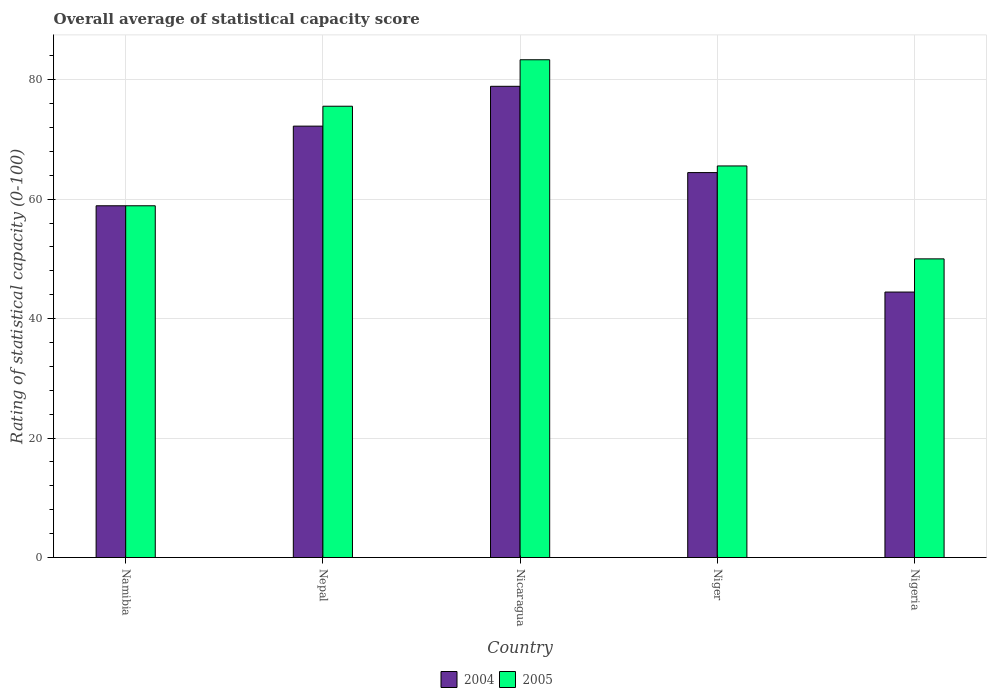How many different coloured bars are there?
Give a very brief answer. 2. How many groups of bars are there?
Provide a short and direct response. 5. How many bars are there on the 5th tick from the left?
Keep it short and to the point. 2. What is the label of the 2nd group of bars from the left?
Offer a very short reply. Nepal. What is the rating of statistical capacity in 2005 in Namibia?
Provide a short and direct response. 58.89. Across all countries, what is the maximum rating of statistical capacity in 2005?
Make the answer very short. 83.33. Across all countries, what is the minimum rating of statistical capacity in 2004?
Offer a terse response. 44.44. In which country was the rating of statistical capacity in 2005 maximum?
Provide a short and direct response. Nicaragua. In which country was the rating of statistical capacity in 2005 minimum?
Make the answer very short. Nigeria. What is the total rating of statistical capacity in 2005 in the graph?
Provide a succinct answer. 333.33. What is the difference between the rating of statistical capacity in 2004 in Namibia and that in Nigeria?
Make the answer very short. 14.44. What is the difference between the rating of statistical capacity in 2004 in Niger and the rating of statistical capacity in 2005 in Nicaragua?
Offer a very short reply. -18.89. What is the average rating of statistical capacity in 2004 per country?
Offer a very short reply. 63.78. In how many countries, is the rating of statistical capacity in 2004 greater than 52?
Offer a terse response. 4. What is the ratio of the rating of statistical capacity in 2005 in Nepal to that in Nigeria?
Your response must be concise. 1.51. Is the rating of statistical capacity in 2004 in Namibia less than that in Niger?
Ensure brevity in your answer.  Yes. Is the difference between the rating of statistical capacity in 2005 in Nepal and Nigeria greater than the difference between the rating of statistical capacity in 2004 in Nepal and Nigeria?
Keep it short and to the point. No. What is the difference between the highest and the second highest rating of statistical capacity in 2005?
Keep it short and to the point. -10. What is the difference between the highest and the lowest rating of statistical capacity in 2005?
Your response must be concise. 33.33. In how many countries, is the rating of statistical capacity in 2004 greater than the average rating of statistical capacity in 2004 taken over all countries?
Your answer should be compact. 3. How many bars are there?
Your answer should be very brief. 10. How many countries are there in the graph?
Provide a short and direct response. 5. What is the difference between two consecutive major ticks on the Y-axis?
Your response must be concise. 20. Does the graph contain any zero values?
Provide a short and direct response. No. Does the graph contain grids?
Your answer should be compact. Yes. What is the title of the graph?
Keep it short and to the point. Overall average of statistical capacity score. What is the label or title of the X-axis?
Your answer should be compact. Country. What is the label or title of the Y-axis?
Give a very brief answer. Rating of statistical capacity (0-100). What is the Rating of statistical capacity (0-100) in 2004 in Namibia?
Offer a terse response. 58.89. What is the Rating of statistical capacity (0-100) of 2005 in Namibia?
Your response must be concise. 58.89. What is the Rating of statistical capacity (0-100) of 2004 in Nepal?
Your answer should be very brief. 72.22. What is the Rating of statistical capacity (0-100) in 2005 in Nepal?
Your answer should be very brief. 75.56. What is the Rating of statistical capacity (0-100) in 2004 in Nicaragua?
Make the answer very short. 78.89. What is the Rating of statistical capacity (0-100) in 2005 in Nicaragua?
Keep it short and to the point. 83.33. What is the Rating of statistical capacity (0-100) in 2004 in Niger?
Provide a succinct answer. 64.44. What is the Rating of statistical capacity (0-100) of 2005 in Niger?
Your response must be concise. 65.56. What is the Rating of statistical capacity (0-100) of 2004 in Nigeria?
Your response must be concise. 44.44. What is the Rating of statistical capacity (0-100) in 2005 in Nigeria?
Offer a very short reply. 50. Across all countries, what is the maximum Rating of statistical capacity (0-100) of 2004?
Provide a short and direct response. 78.89. Across all countries, what is the maximum Rating of statistical capacity (0-100) of 2005?
Your response must be concise. 83.33. Across all countries, what is the minimum Rating of statistical capacity (0-100) of 2004?
Offer a terse response. 44.44. What is the total Rating of statistical capacity (0-100) in 2004 in the graph?
Provide a succinct answer. 318.89. What is the total Rating of statistical capacity (0-100) of 2005 in the graph?
Give a very brief answer. 333.33. What is the difference between the Rating of statistical capacity (0-100) in 2004 in Namibia and that in Nepal?
Ensure brevity in your answer.  -13.33. What is the difference between the Rating of statistical capacity (0-100) in 2005 in Namibia and that in Nepal?
Keep it short and to the point. -16.67. What is the difference between the Rating of statistical capacity (0-100) in 2005 in Namibia and that in Nicaragua?
Your response must be concise. -24.44. What is the difference between the Rating of statistical capacity (0-100) in 2004 in Namibia and that in Niger?
Your answer should be compact. -5.56. What is the difference between the Rating of statistical capacity (0-100) in 2005 in Namibia and that in Niger?
Offer a terse response. -6.67. What is the difference between the Rating of statistical capacity (0-100) in 2004 in Namibia and that in Nigeria?
Provide a succinct answer. 14.44. What is the difference between the Rating of statistical capacity (0-100) of 2005 in Namibia and that in Nigeria?
Your response must be concise. 8.89. What is the difference between the Rating of statistical capacity (0-100) in 2004 in Nepal and that in Nicaragua?
Provide a short and direct response. -6.67. What is the difference between the Rating of statistical capacity (0-100) of 2005 in Nepal and that in Nicaragua?
Your response must be concise. -7.78. What is the difference between the Rating of statistical capacity (0-100) of 2004 in Nepal and that in Niger?
Provide a short and direct response. 7.78. What is the difference between the Rating of statistical capacity (0-100) in 2004 in Nepal and that in Nigeria?
Offer a terse response. 27.78. What is the difference between the Rating of statistical capacity (0-100) in 2005 in Nepal and that in Nigeria?
Ensure brevity in your answer.  25.56. What is the difference between the Rating of statistical capacity (0-100) in 2004 in Nicaragua and that in Niger?
Your answer should be compact. 14.44. What is the difference between the Rating of statistical capacity (0-100) of 2005 in Nicaragua and that in Niger?
Provide a succinct answer. 17.78. What is the difference between the Rating of statistical capacity (0-100) in 2004 in Nicaragua and that in Nigeria?
Give a very brief answer. 34.44. What is the difference between the Rating of statistical capacity (0-100) in 2005 in Nicaragua and that in Nigeria?
Give a very brief answer. 33.33. What is the difference between the Rating of statistical capacity (0-100) in 2005 in Niger and that in Nigeria?
Your answer should be compact. 15.56. What is the difference between the Rating of statistical capacity (0-100) in 2004 in Namibia and the Rating of statistical capacity (0-100) in 2005 in Nepal?
Offer a terse response. -16.67. What is the difference between the Rating of statistical capacity (0-100) of 2004 in Namibia and the Rating of statistical capacity (0-100) of 2005 in Nicaragua?
Provide a succinct answer. -24.44. What is the difference between the Rating of statistical capacity (0-100) in 2004 in Namibia and the Rating of statistical capacity (0-100) in 2005 in Niger?
Your answer should be very brief. -6.67. What is the difference between the Rating of statistical capacity (0-100) in 2004 in Namibia and the Rating of statistical capacity (0-100) in 2005 in Nigeria?
Ensure brevity in your answer.  8.89. What is the difference between the Rating of statistical capacity (0-100) of 2004 in Nepal and the Rating of statistical capacity (0-100) of 2005 in Nicaragua?
Provide a short and direct response. -11.11. What is the difference between the Rating of statistical capacity (0-100) of 2004 in Nepal and the Rating of statistical capacity (0-100) of 2005 in Nigeria?
Your answer should be very brief. 22.22. What is the difference between the Rating of statistical capacity (0-100) in 2004 in Nicaragua and the Rating of statistical capacity (0-100) in 2005 in Niger?
Make the answer very short. 13.33. What is the difference between the Rating of statistical capacity (0-100) of 2004 in Nicaragua and the Rating of statistical capacity (0-100) of 2005 in Nigeria?
Provide a succinct answer. 28.89. What is the difference between the Rating of statistical capacity (0-100) in 2004 in Niger and the Rating of statistical capacity (0-100) in 2005 in Nigeria?
Offer a terse response. 14.44. What is the average Rating of statistical capacity (0-100) of 2004 per country?
Your response must be concise. 63.78. What is the average Rating of statistical capacity (0-100) of 2005 per country?
Offer a very short reply. 66.67. What is the difference between the Rating of statistical capacity (0-100) in 2004 and Rating of statistical capacity (0-100) in 2005 in Nicaragua?
Ensure brevity in your answer.  -4.44. What is the difference between the Rating of statistical capacity (0-100) of 2004 and Rating of statistical capacity (0-100) of 2005 in Niger?
Keep it short and to the point. -1.11. What is the difference between the Rating of statistical capacity (0-100) of 2004 and Rating of statistical capacity (0-100) of 2005 in Nigeria?
Offer a very short reply. -5.56. What is the ratio of the Rating of statistical capacity (0-100) in 2004 in Namibia to that in Nepal?
Your answer should be very brief. 0.82. What is the ratio of the Rating of statistical capacity (0-100) in 2005 in Namibia to that in Nepal?
Give a very brief answer. 0.78. What is the ratio of the Rating of statistical capacity (0-100) of 2004 in Namibia to that in Nicaragua?
Give a very brief answer. 0.75. What is the ratio of the Rating of statistical capacity (0-100) in 2005 in Namibia to that in Nicaragua?
Your answer should be very brief. 0.71. What is the ratio of the Rating of statistical capacity (0-100) in 2004 in Namibia to that in Niger?
Ensure brevity in your answer.  0.91. What is the ratio of the Rating of statistical capacity (0-100) of 2005 in Namibia to that in Niger?
Provide a succinct answer. 0.9. What is the ratio of the Rating of statistical capacity (0-100) of 2004 in Namibia to that in Nigeria?
Provide a short and direct response. 1.32. What is the ratio of the Rating of statistical capacity (0-100) of 2005 in Namibia to that in Nigeria?
Ensure brevity in your answer.  1.18. What is the ratio of the Rating of statistical capacity (0-100) of 2004 in Nepal to that in Nicaragua?
Your response must be concise. 0.92. What is the ratio of the Rating of statistical capacity (0-100) of 2005 in Nepal to that in Nicaragua?
Provide a succinct answer. 0.91. What is the ratio of the Rating of statistical capacity (0-100) in 2004 in Nepal to that in Niger?
Your answer should be compact. 1.12. What is the ratio of the Rating of statistical capacity (0-100) of 2005 in Nepal to that in Niger?
Offer a very short reply. 1.15. What is the ratio of the Rating of statistical capacity (0-100) of 2004 in Nepal to that in Nigeria?
Provide a succinct answer. 1.62. What is the ratio of the Rating of statistical capacity (0-100) in 2005 in Nepal to that in Nigeria?
Your answer should be very brief. 1.51. What is the ratio of the Rating of statistical capacity (0-100) in 2004 in Nicaragua to that in Niger?
Offer a terse response. 1.22. What is the ratio of the Rating of statistical capacity (0-100) of 2005 in Nicaragua to that in Niger?
Offer a terse response. 1.27. What is the ratio of the Rating of statistical capacity (0-100) in 2004 in Nicaragua to that in Nigeria?
Provide a succinct answer. 1.77. What is the ratio of the Rating of statistical capacity (0-100) in 2005 in Nicaragua to that in Nigeria?
Keep it short and to the point. 1.67. What is the ratio of the Rating of statistical capacity (0-100) in 2004 in Niger to that in Nigeria?
Provide a short and direct response. 1.45. What is the ratio of the Rating of statistical capacity (0-100) in 2005 in Niger to that in Nigeria?
Provide a succinct answer. 1.31. What is the difference between the highest and the second highest Rating of statistical capacity (0-100) of 2004?
Your answer should be very brief. 6.67. What is the difference between the highest and the second highest Rating of statistical capacity (0-100) of 2005?
Make the answer very short. 7.78. What is the difference between the highest and the lowest Rating of statistical capacity (0-100) in 2004?
Your answer should be compact. 34.44. What is the difference between the highest and the lowest Rating of statistical capacity (0-100) in 2005?
Provide a succinct answer. 33.33. 